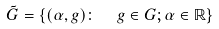Convert formula to latex. <formula><loc_0><loc_0><loc_500><loc_500>\tilde { G } = \left \{ ( \alpha , g ) \colon \ \ g \in G ; \alpha \in { \mathbb { R } } \right \}</formula> 